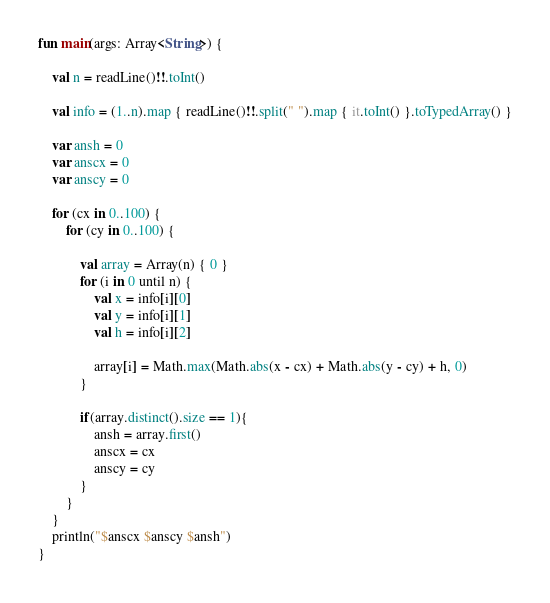<code> <loc_0><loc_0><loc_500><loc_500><_Kotlin_>fun main(args: Array<String>) {

    val n = readLine()!!.toInt()

    val info = (1..n).map { readLine()!!.split(" ").map { it.toInt() }.toTypedArray() }

    var ansh = 0
    var anscx = 0
    var anscy = 0

    for (cx in 0..100) {
        for (cy in 0..100) {

            val array = Array(n) { 0 }
            for (i in 0 until n) {
                val x = info[i][0]
                val y = info[i][1]
                val h = info[i][2]

                array[i] = Math.max(Math.abs(x - cx) + Math.abs(y - cy) + h, 0)
            }
            
            if(array.distinct().size == 1){
                ansh = array.first()
                anscx = cx
                anscy = cy
            }
        }
    }
    println("$anscx $anscy $ansh")
}</code> 